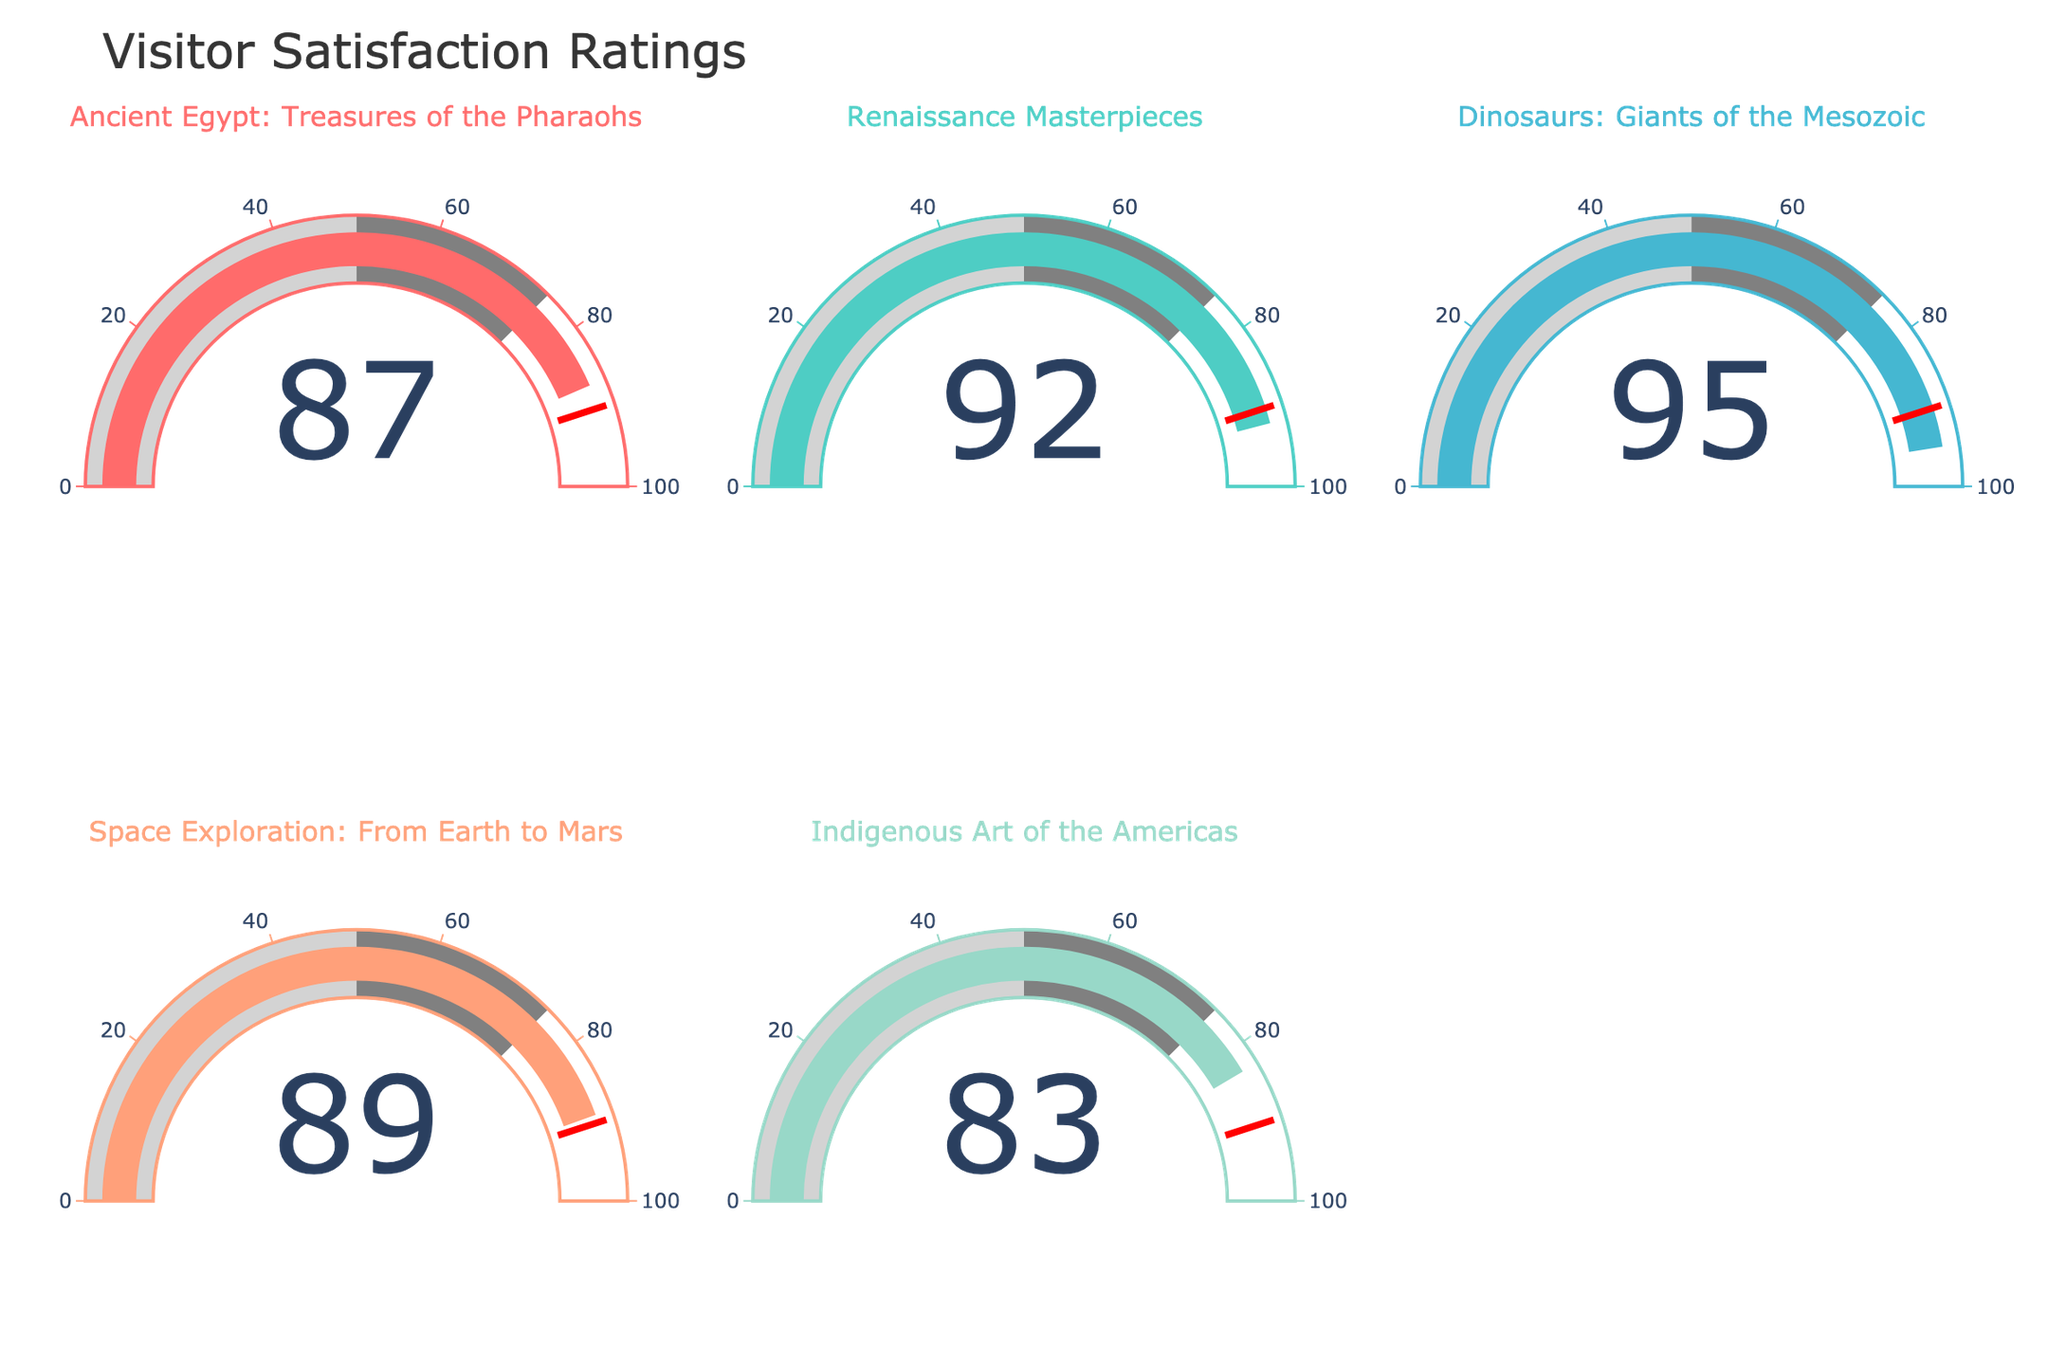What's the satisfaction rating for the Ancient Egypt: Treasures of the Pharaohs exhibit? The satisfaction rating is shown directly on the gauge chart for the Ancient Egypt: Treasures of the Pharaohs exhibit.
Answer: 87 Which exhibit has the highest satisfaction rating? Look at the numbers displayed on each gauge chart. The highest number is 95 for the Dinosaurs: Giants of the Mesozoic exhibit.
Answer: Dinosaurs: Giants of the Mesozoic Which exhibit has the lowest satisfaction rating? Compare the numbers on each gauge chart. The lowest number is 83 for the Indigenous Art of the Americas exhibit.
Answer: Indigenous Art of the Americas How many exhibits have a satisfaction rating of 90 or higher? Identify the gauge charts with numbers 90 or higher. They are Renaissance Masterpieces (92) and Dinosaurs: Giants of the Mesozoic (95).
Answer: 2 What is the average satisfaction rating of all the exhibits? Add the satisfaction ratings of all exhibits (87 + 92 + 95 + 89 + 83) and divide by the number of exhibits (5). The total is 446, and the average is 446/5 = 89.2
Answer: 89.2 Which exhibit has a satisfaction rating closest to 90? Look at the numbers displayed on each gauge and find the one closest to 90. Space Exploration: From Earth to Mars has a rating of 89, which is closest to 90.
Answer: Space Exploration: From Earth to Mars What is the difference in satisfaction ratings between the highest and lowest-rated exhibits? Subtract the lowest satisfaction rating (Indigenous Art of the Americas, 83) from the highest satisfaction rating (Dinosaurs: Giants of the Mesozoic, 95). The difference is 95 - 83 = 12.
Answer: 12 